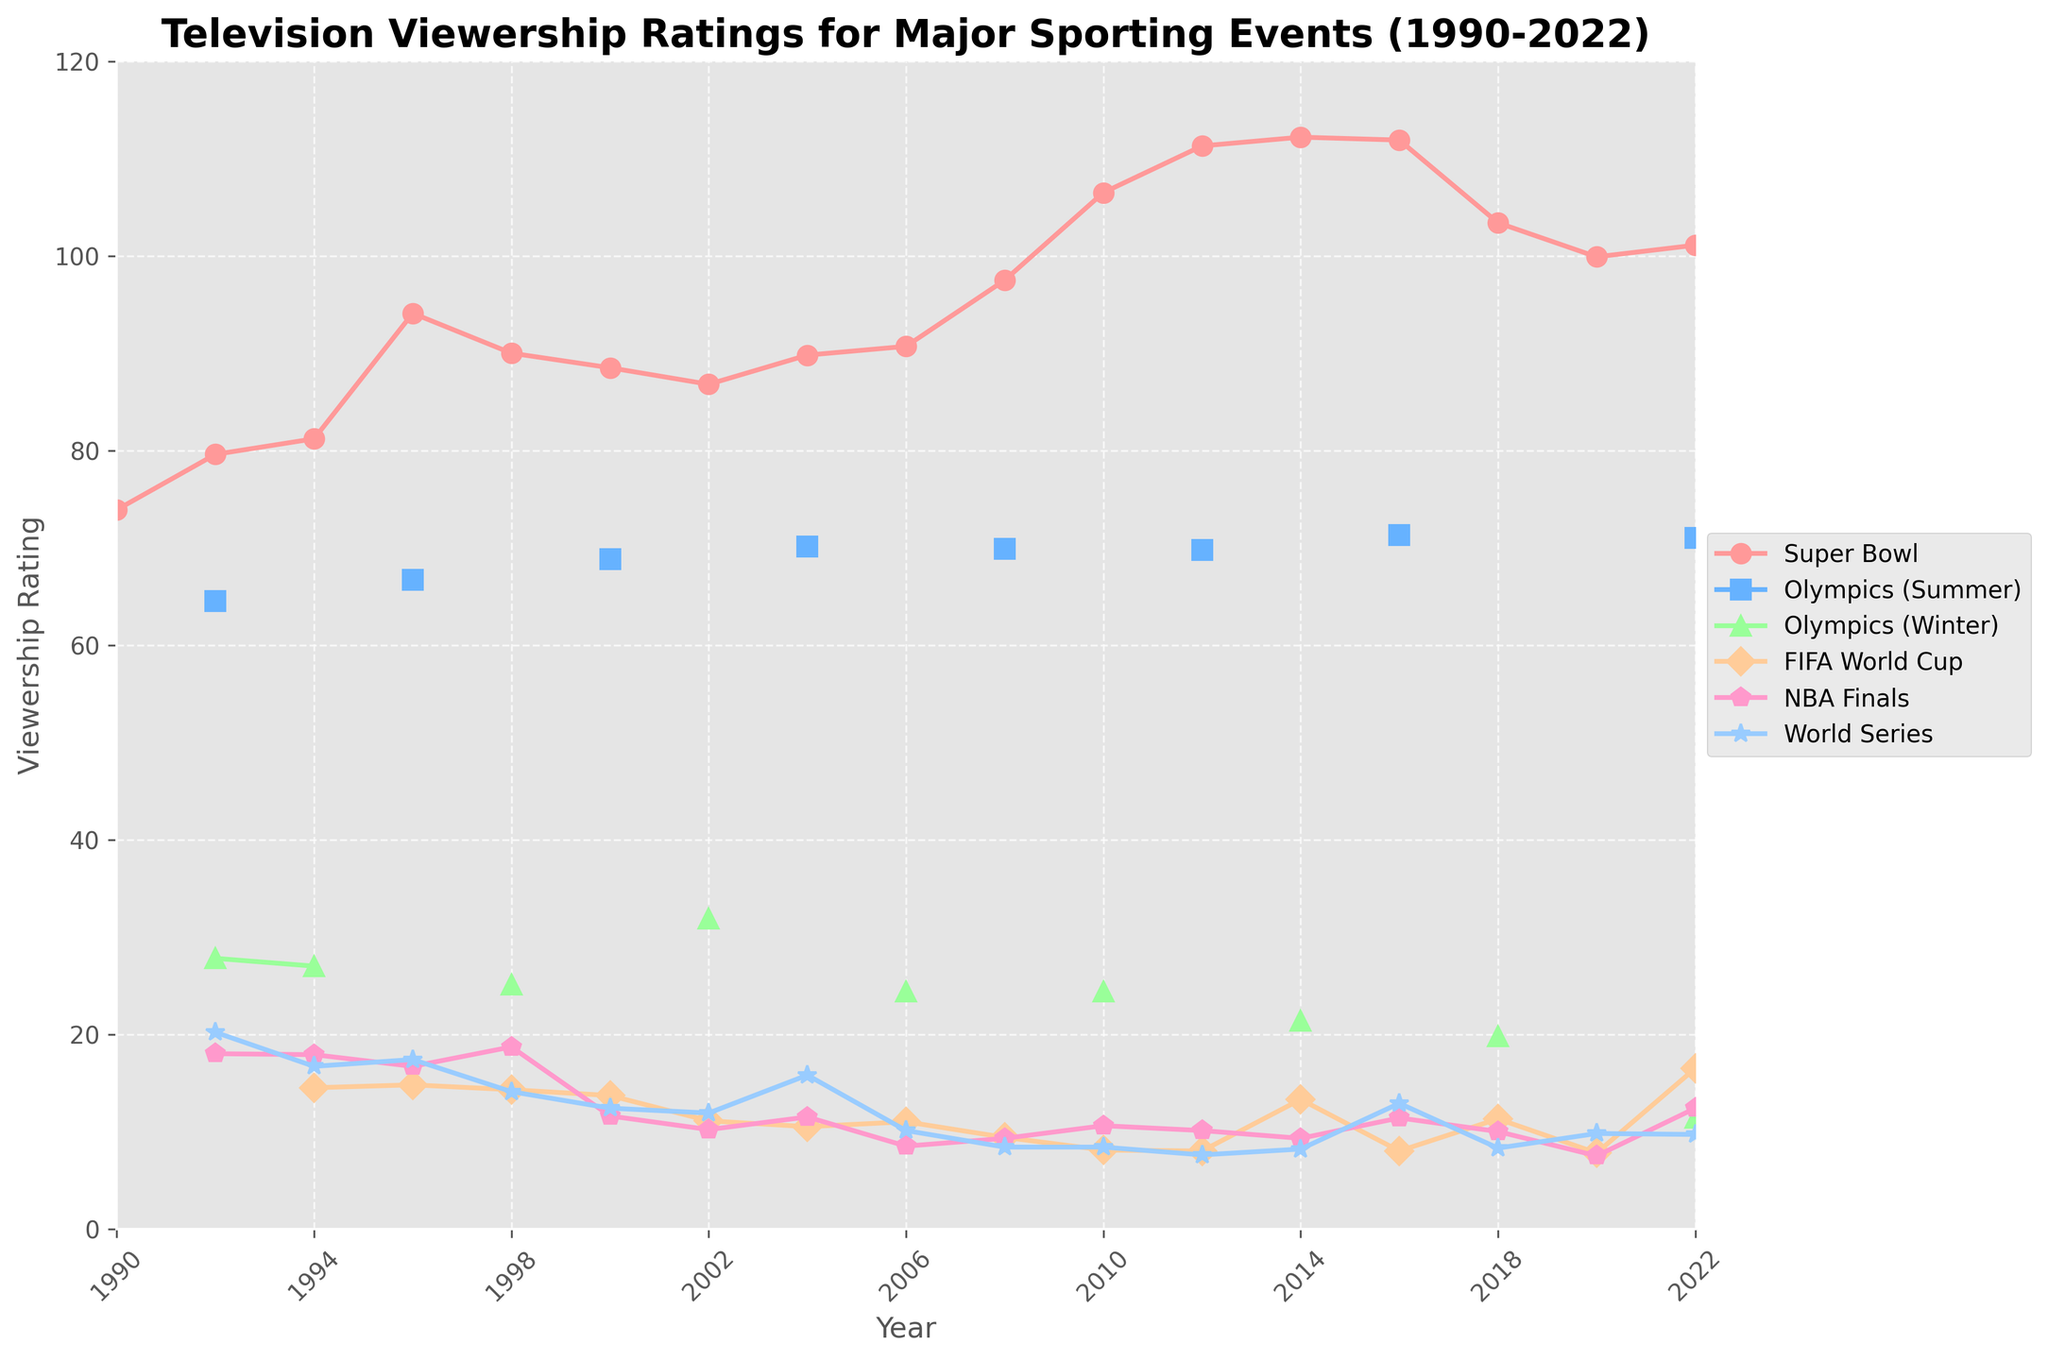Which sporting event has the highest viewership rating across all years? By examining the peak points in the figure where the lines are at their highest, we can see that the Super Bowl in 2014 has the highest rating at 112.2.
Answer: Super Bowl in 2014 Between 2000 and 2022, did the Summer Olympics ever surpass the Super Bowl in viewership ratings? By visually inspecting the lines for the Summer Olympics and the Super Bowl from 2000 to 2022, we see that the Super Bowl consistently has higher ratings than the Summer Olympics in all those years.
Answer: No How did the viewership ratings of the FIFA World Cup change from 1994 to 2014? By looking at the FIFA World Cup data points on the chart from 1994 to 2014, we observe that the ratings declined from 14.5 in 1994 to 13.3 in 2014, with a low point at 8.0 in 2008 and 2012.
Answer: Declined In what year did the NBA Finals have the lowest viewership rating, and what was that rating? By finding the lowest point on the line for the NBA Finals, we see that in 2020, the viewership rating was at its lowest at 7.5.
Answer: 2020, 7.5 Which year had a higher viewership rating for the Winter Olympics: 1992 or 1998? By comparing the ratings for the Winter Olympics in 1992 and 1998, we see 27.8 in 1992 and 25.1 in 1998.
Answer: 1992 What is the average viewership rating for the Super Bowl from 1996 to 2006 (inclusive)? The Super Bowl ratings are 94.1 (1996), 90.0 (1998), 88.5 (2000), 86.8 (2002), 89.8 (2004), and 90.7 (2006). Summing these gives 540, divided by 6 years results in an average of 90.0.
Answer: 90.0 Between the World Series and the FIFA World Cup, which had more consistent viewership ratings between 2000 and 2020? By examining the fluctuations in the World Series and FIFA World Cup lines from 2000 to 2020, the World Series shows less variation in its ratings compared to the more dramatic changes in FIFA World Cup's ratings.
Answer: World Series Which event saw an increase in viewership ratings from 2008 to 2012? By checking the lines for each event between 2008 and 2012, the Super Bowl had an increase from 97.5 to 111.3.
Answer: Super Bowl What was the viewership rating difference between the highest and lowest-rated NBA Finals years shown in the chart? The highest NBA Finals viewership rating is 18.7 in 1998, and the lowest is 7.5 in 2020, giving a difference of 11.2.
Answer: 11.2 In how many years did the Super Bowl's ratings exceed 100? By counting the number of data points for the Super Bowl line that are above the 100 mark, we find they are in 3 years: 2010, 2012, and 2014.
Answer: 3 